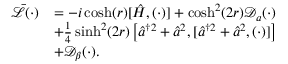<formula> <loc_0><loc_0><loc_500><loc_500>\begin{array} { r l } { \bar { \mathcal { L } } ( \cdot ) } & { = - i \cosh ( r ) [ \hat { H } , ( \cdot ) ] + \cosh ^ { 2 } ( 2 r ) \mathcal { D } _ { a } ( \cdot ) } \\ & { + \frac { 1 } { 4 } \sinh ^ { 2 } ( 2 r ) \left [ \hat { a } ^ { \dagger 2 } + \hat { a } ^ { 2 } , [ \hat { a } ^ { \dagger 2 } + \hat { a } ^ { 2 } , ( \cdot ) ] \right ] } \\ & { + \mathcal { D } _ { \beta } ( \cdot ) . } \end{array}</formula> 